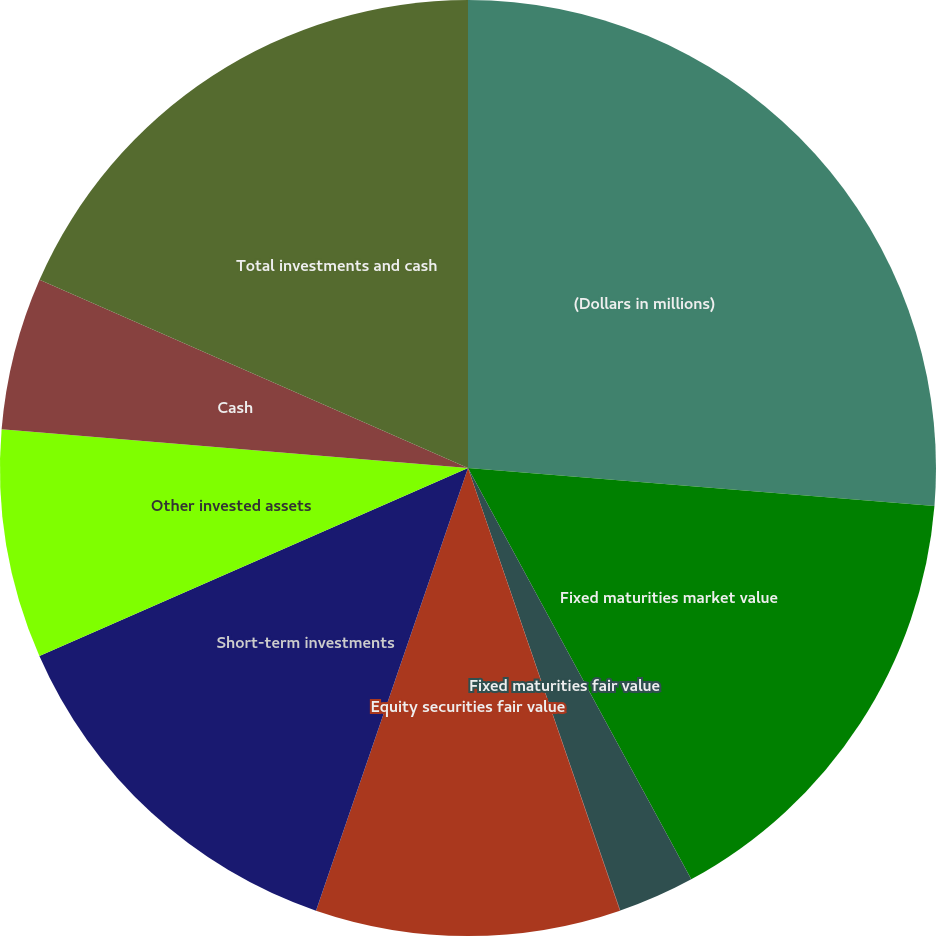Convert chart. <chart><loc_0><loc_0><loc_500><loc_500><pie_chart><fcel>(Dollars in millions)<fcel>Fixed maturities market value<fcel>Fixed maturities fair value<fcel>Equity securities market value<fcel>Equity securities fair value<fcel>Short-term investments<fcel>Other invested assets<fcel>Cash<fcel>Total investments and cash<nl><fcel>26.3%<fcel>15.79%<fcel>2.64%<fcel>0.01%<fcel>10.53%<fcel>13.16%<fcel>7.9%<fcel>5.27%<fcel>18.41%<nl></chart> 